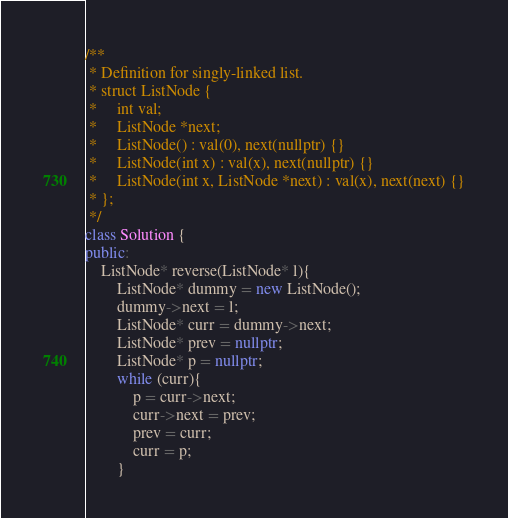Convert code to text. <code><loc_0><loc_0><loc_500><loc_500><_C++_>/**
 * Definition for singly-linked list.
 * struct ListNode {
 *     int val;
 *     ListNode *next;
 *     ListNode() : val(0), next(nullptr) {}
 *     ListNode(int x) : val(x), next(nullptr) {}
 *     ListNode(int x, ListNode *next) : val(x), next(next) {}
 * };
 */
class Solution {
public:
    ListNode* reverse(ListNode* l){
        ListNode* dummy = new ListNode();
        dummy->next = l;
        ListNode* curr = dummy->next;
        ListNode* prev = nullptr;
        ListNode* p = nullptr;
        while (curr){
            p = curr->next;
            curr->next = prev;
            prev = curr;
            curr = p;
        }</code> 